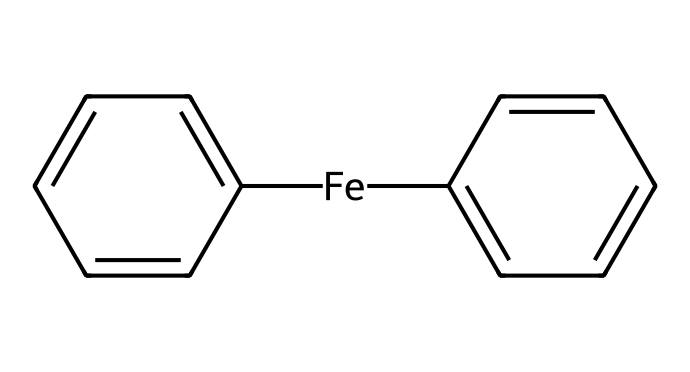What is the central metal atom in ferrocene? The chemical structure indicates the presence of an iron atom, which is denoted by the symbol "Fe" in the SMILES representation.
Answer: iron How many cyclopentadienyl rings are attached to the iron center? The structure shows two identical cyclopentadienyl rings (C1=CC=CC=C1), which are indicated by the repeating segments around the iron.
Answer: two What oxidation state is iron in this compound? In ferrocene, iron typically exhibits an oxidation state of +2, as it is sandwiched between two anionic cyclopentadienyl ligands, which collectively have a charge of -2.
Answer: +2 What type of bonding occurs between the iron and the cyclopentadienyl rings? The bonding is described as coordinate covalent bonding, where electron pairs from the cyclopentadienyl ligands are shared with the iron center.
Answer: coordinate covalent What is the overall charge of the ferrocene molecule? Since the two cyclopentadienyl rings are each negatively charged, and the iron is neutral in this context, the overall molecule has a net charge of zero.
Answer: zero What is the hybridization of the iron atom in ferrocene? Given the geometry and bonding in ferrocene, the iron atom is generally considered to have a hybridization state of d²sp³ due to its coordination with the two rings.
Answer: d²sp³ Which type of chemical compound does ferrocene represent? Ferrocene is classified as an organometallic compound because it contains a metal atom bonded to organic components (the cyclopentadienyl rings).
Answer: organometallic 